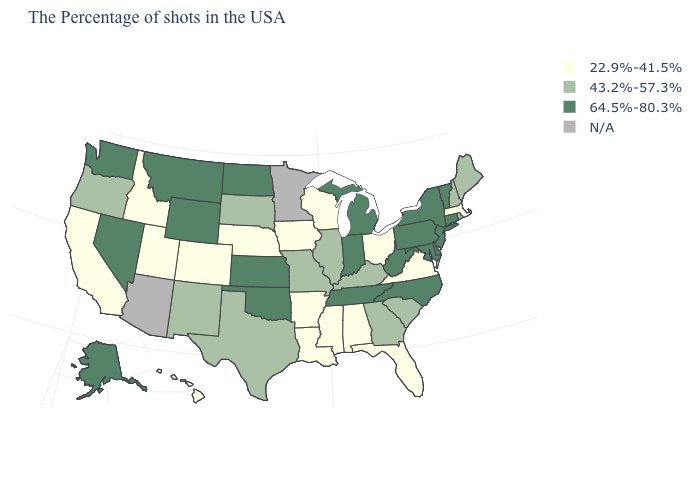What is the lowest value in the USA?
Answer briefly. 22.9%-41.5%. What is the value of Ohio?
Concise answer only. 22.9%-41.5%. Name the states that have a value in the range 43.2%-57.3%?
Short answer required. Maine, Rhode Island, New Hampshire, South Carolina, Georgia, Kentucky, Illinois, Missouri, Texas, South Dakota, New Mexico, Oregon. Which states have the lowest value in the USA?
Be succinct. Massachusetts, Virginia, Ohio, Florida, Alabama, Wisconsin, Mississippi, Louisiana, Arkansas, Iowa, Nebraska, Colorado, Utah, Idaho, California, Hawaii. Does Virginia have the lowest value in the USA?
Give a very brief answer. Yes. Name the states that have a value in the range 22.9%-41.5%?
Give a very brief answer. Massachusetts, Virginia, Ohio, Florida, Alabama, Wisconsin, Mississippi, Louisiana, Arkansas, Iowa, Nebraska, Colorado, Utah, Idaho, California, Hawaii. Name the states that have a value in the range 22.9%-41.5%?
Short answer required. Massachusetts, Virginia, Ohio, Florida, Alabama, Wisconsin, Mississippi, Louisiana, Arkansas, Iowa, Nebraska, Colorado, Utah, Idaho, California, Hawaii. Name the states that have a value in the range 43.2%-57.3%?
Concise answer only. Maine, Rhode Island, New Hampshire, South Carolina, Georgia, Kentucky, Illinois, Missouri, Texas, South Dakota, New Mexico, Oregon. Does Wisconsin have the lowest value in the USA?
Short answer required. Yes. How many symbols are there in the legend?
Be succinct. 4. Which states have the lowest value in the South?
Write a very short answer. Virginia, Florida, Alabama, Mississippi, Louisiana, Arkansas. What is the value of Missouri?
Quick response, please. 43.2%-57.3%. Name the states that have a value in the range N/A?
Keep it brief. Minnesota, Arizona. Name the states that have a value in the range N/A?
Answer briefly. Minnesota, Arizona. 